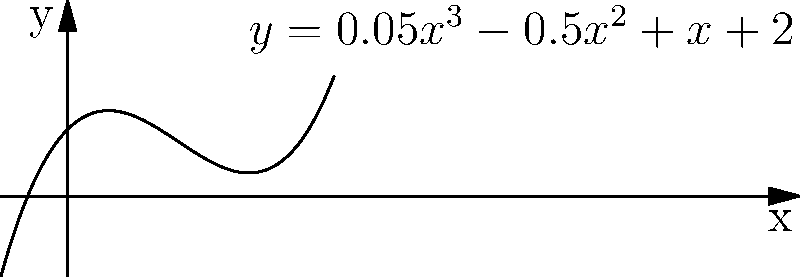You're designing a decorative floor inlay pattern using the polynomial function $y = 0.05x^3 - 0.5x^2 + x + 2$. The client wants the pattern to have a maximum width of 10 feet. What is the approximate x-coordinate of the local minimum point of this curve, which will determine the narrowest part of the inlay? To find the local minimum of the polynomial function, we need to follow these steps:

1) The given function is $f(x) = 0.05x^3 - 0.5x^2 + x + 2$

2) To find the local minimum, we need to find where the derivative of the function equals zero.

3) The derivative of $f(x)$ is:
   $f'(x) = 0.15x^2 - x + 1$

4) Set $f'(x) = 0$:
   $0.15x^2 - x + 1 = 0$

5) This is a quadratic equation. We can solve it using the quadratic formula:
   $x = \frac{-b \pm \sqrt{b^2 - 4ac}}{2a}$

   Where $a = 0.15$, $b = -1$, and $c = 1$

6) Plugging into the quadratic formula:
   $x = \frac{1 \pm \sqrt{1 - 4(0.15)(1)}}{2(0.15)}$

7) Simplifying:
   $x = \frac{1 \pm \sqrt{0.4}}{0.3}$

8) This gives us two solutions:
   $x \approx 5.39$ or $x \approx 1.28$

9) The smaller value, $x \approx 1.28$, corresponds to the local minimum.
Answer: 1.28 feet 